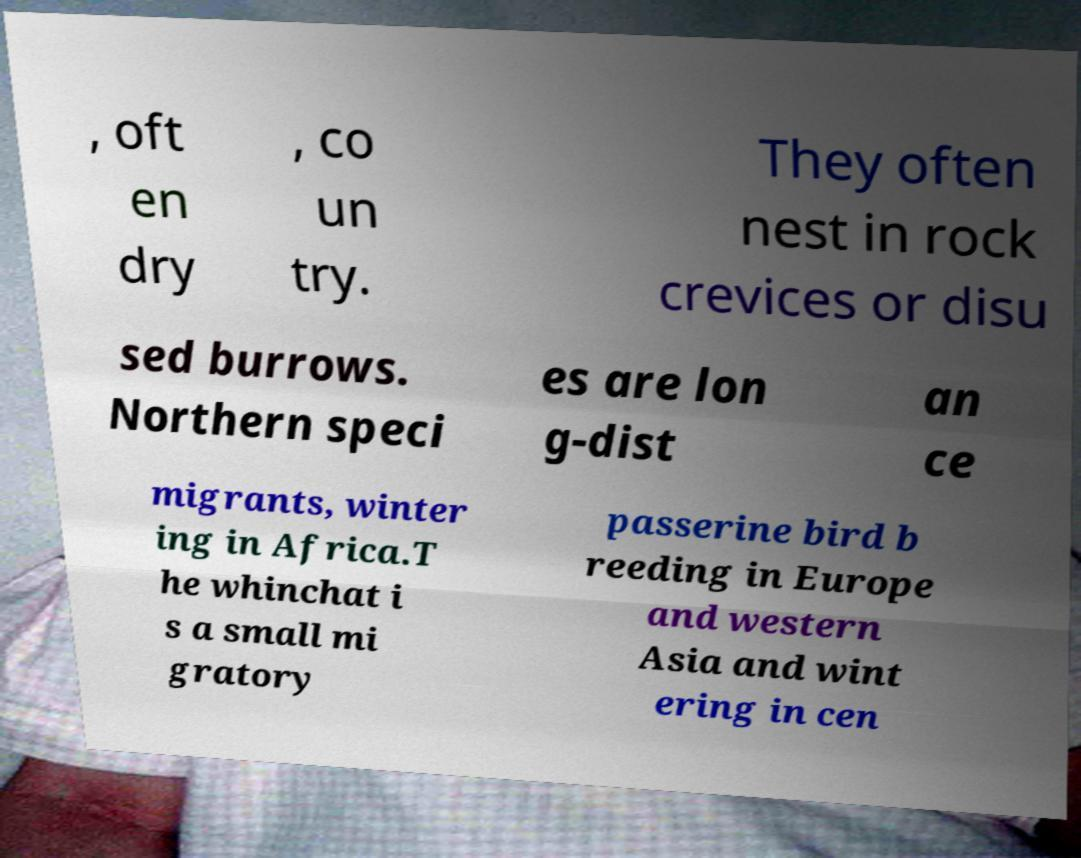Can you read and provide the text displayed in the image?This photo seems to have some interesting text. Can you extract and type it out for me? , oft en dry , co un try. They often nest in rock crevices or disu sed burrows. Northern speci es are lon g-dist an ce migrants, winter ing in Africa.T he whinchat i s a small mi gratory passerine bird b reeding in Europe and western Asia and wint ering in cen 